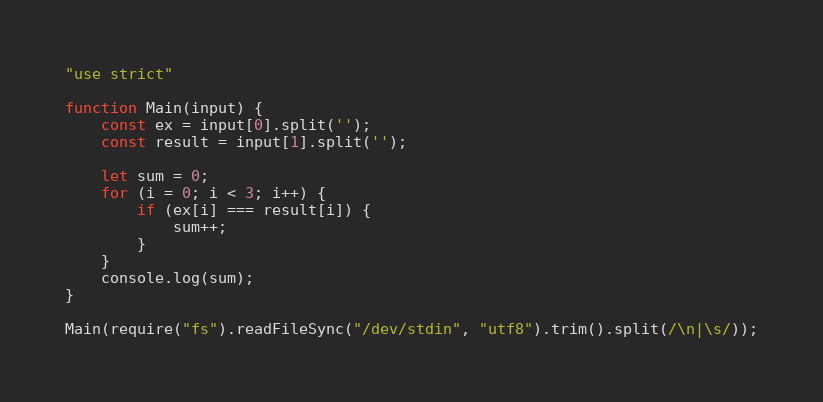Convert code to text. <code><loc_0><loc_0><loc_500><loc_500><_JavaScript_>"use strict"

function Main(input) {
    const ex = input[0].split('');
    const result = input[1].split('');

    let sum = 0;
    for (i = 0; i < 3; i++) {
        if (ex[i] === result[i]) {
            sum++;
        }
    }
    console.log(sum);
}

Main(require("fs").readFileSync("/dev/stdin", "utf8").trim().split(/\n|\s/));</code> 